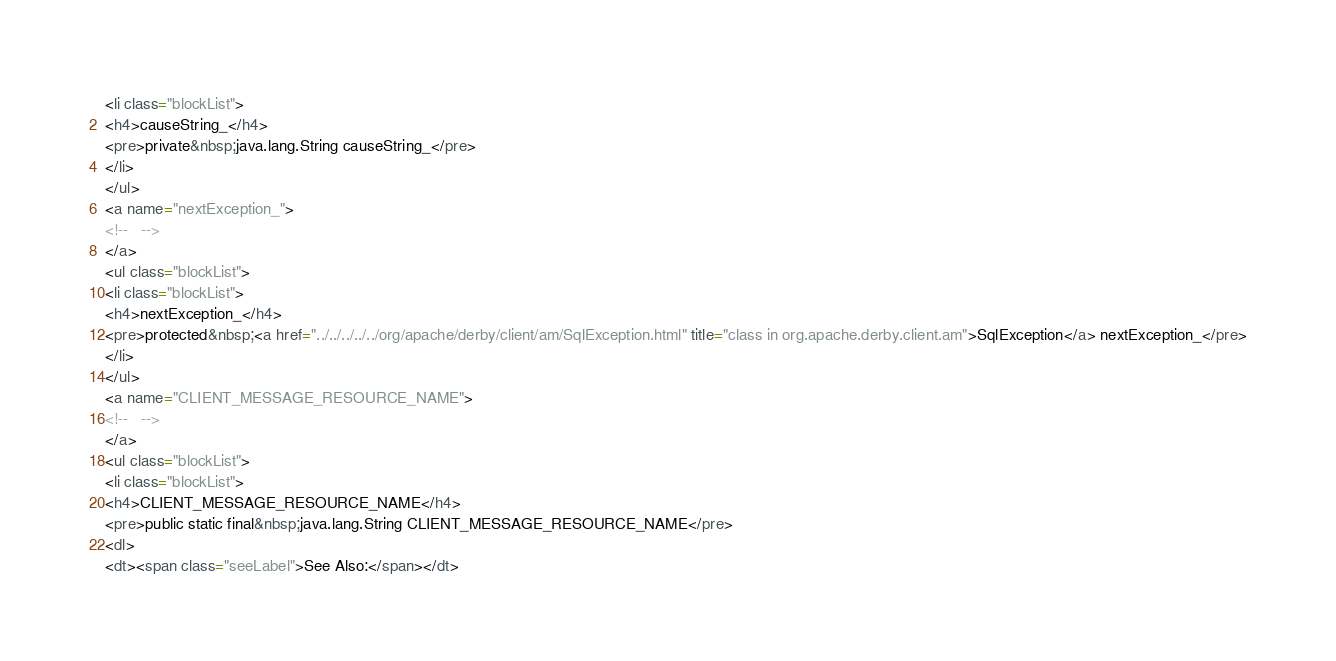<code> <loc_0><loc_0><loc_500><loc_500><_HTML_><li class="blockList">
<h4>causeString_</h4>
<pre>private&nbsp;java.lang.String causeString_</pre>
</li>
</ul>
<a name="nextException_">
<!--   -->
</a>
<ul class="blockList">
<li class="blockList">
<h4>nextException_</h4>
<pre>protected&nbsp;<a href="../../../../../org/apache/derby/client/am/SqlException.html" title="class in org.apache.derby.client.am">SqlException</a> nextException_</pre>
</li>
</ul>
<a name="CLIENT_MESSAGE_RESOURCE_NAME">
<!--   -->
</a>
<ul class="blockList">
<li class="blockList">
<h4>CLIENT_MESSAGE_RESOURCE_NAME</h4>
<pre>public static final&nbsp;java.lang.String CLIENT_MESSAGE_RESOURCE_NAME</pre>
<dl>
<dt><span class="seeLabel">See Also:</span></dt></code> 